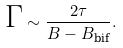<formula> <loc_0><loc_0><loc_500><loc_500>\text {$\Gamma$} \sim \frac { 2 \tau } { B - B _ { \text {bif} } } .</formula> 